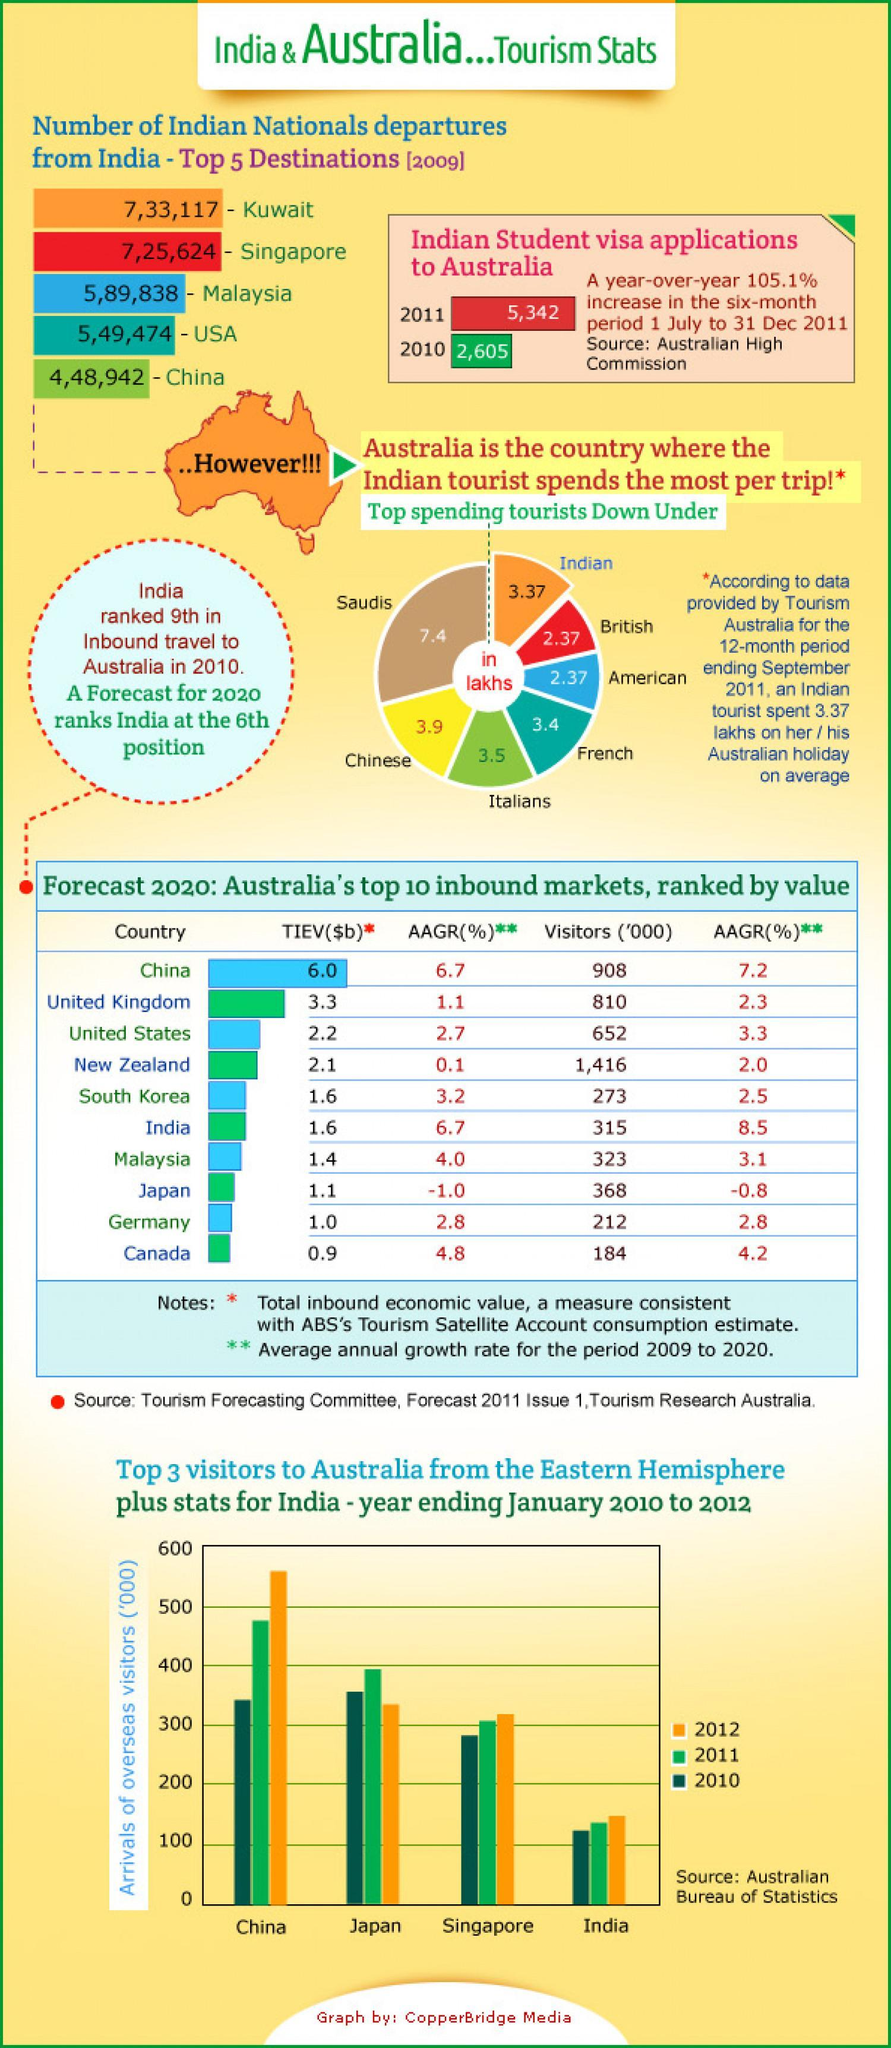As per forecast 2020, from which country is the second highest visitor count
Answer the question with a short phrase. China what is the indian nationals departures to Singapore and Malaysia 1315462 what has been the increase in the six-month period 105.1% who was 2nd top visitor to Australia in 2011 from eastern hemisphere japan how many lakhs do an Indian and British tourist spend in Australia 5.74 